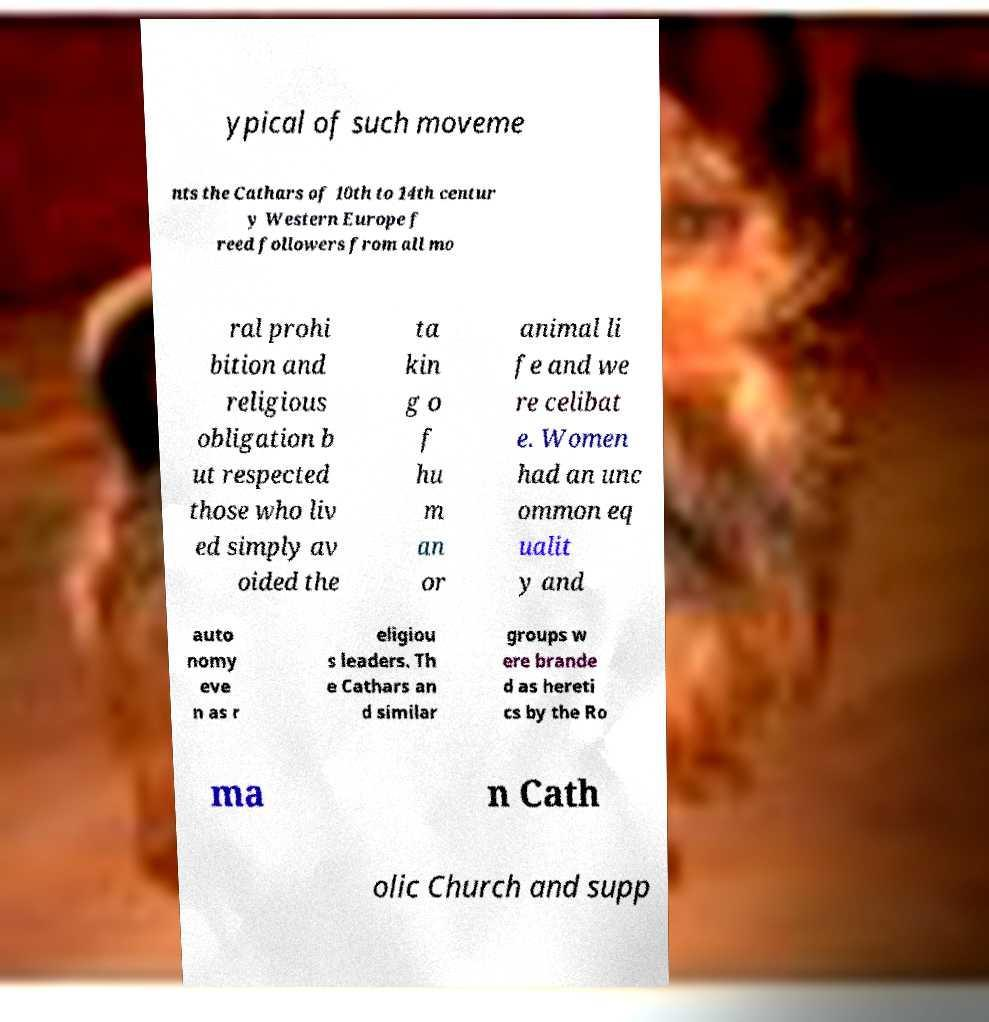Can you accurately transcribe the text from the provided image for me? ypical of such moveme nts the Cathars of 10th to 14th centur y Western Europe f reed followers from all mo ral prohi bition and religious obligation b ut respected those who liv ed simply av oided the ta kin g o f hu m an or animal li fe and we re celibat e. Women had an unc ommon eq ualit y and auto nomy eve n as r eligiou s leaders. Th e Cathars an d similar groups w ere brande d as hereti cs by the Ro ma n Cath olic Church and supp 